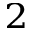Convert formula to latex. <formula><loc_0><loc_0><loc_500><loc_500>_ { 2 }</formula> 